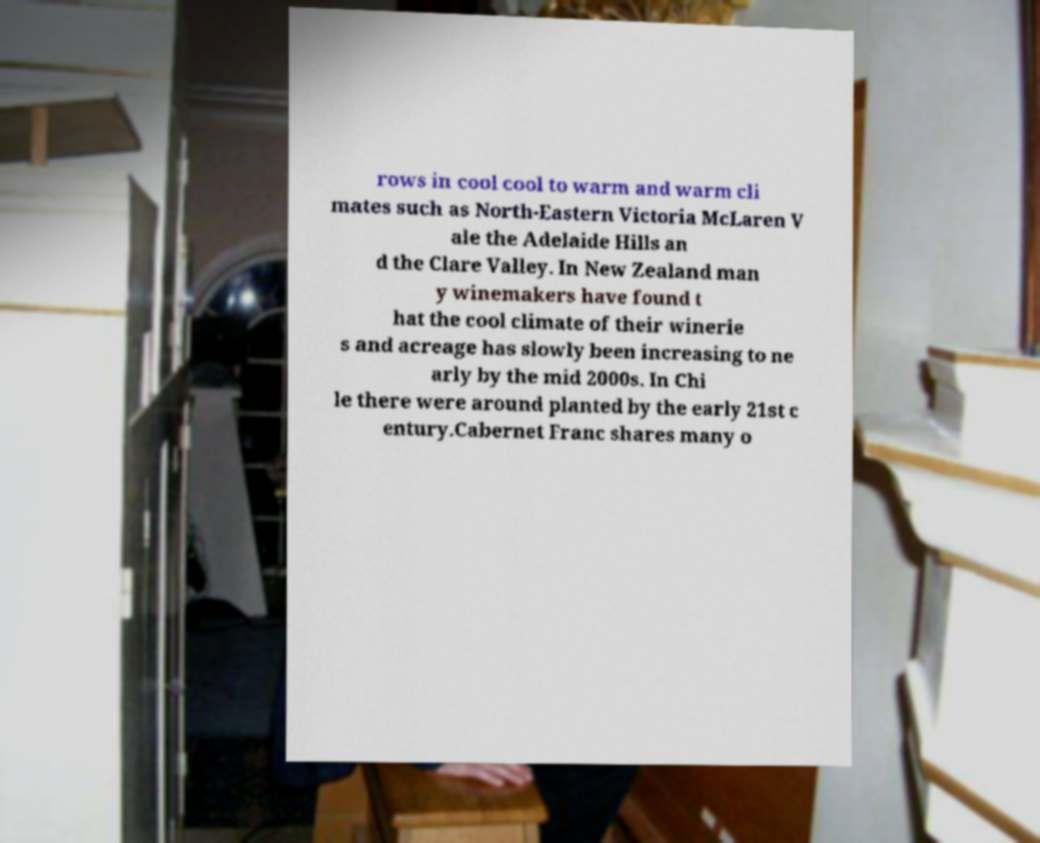What messages or text are displayed in this image? I need them in a readable, typed format. rows in cool cool to warm and warm cli mates such as North-Eastern Victoria McLaren V ale the Adelaide Hills an d the Clare Valley. In New Zealand man y winemakers have found t hat the cool climate of their winerie s and acreage has slowly been increasing to ne arly by the mid 2000s. In Chi le there were around planted by the early 21st c entury.Cabernet Franc shares many o 